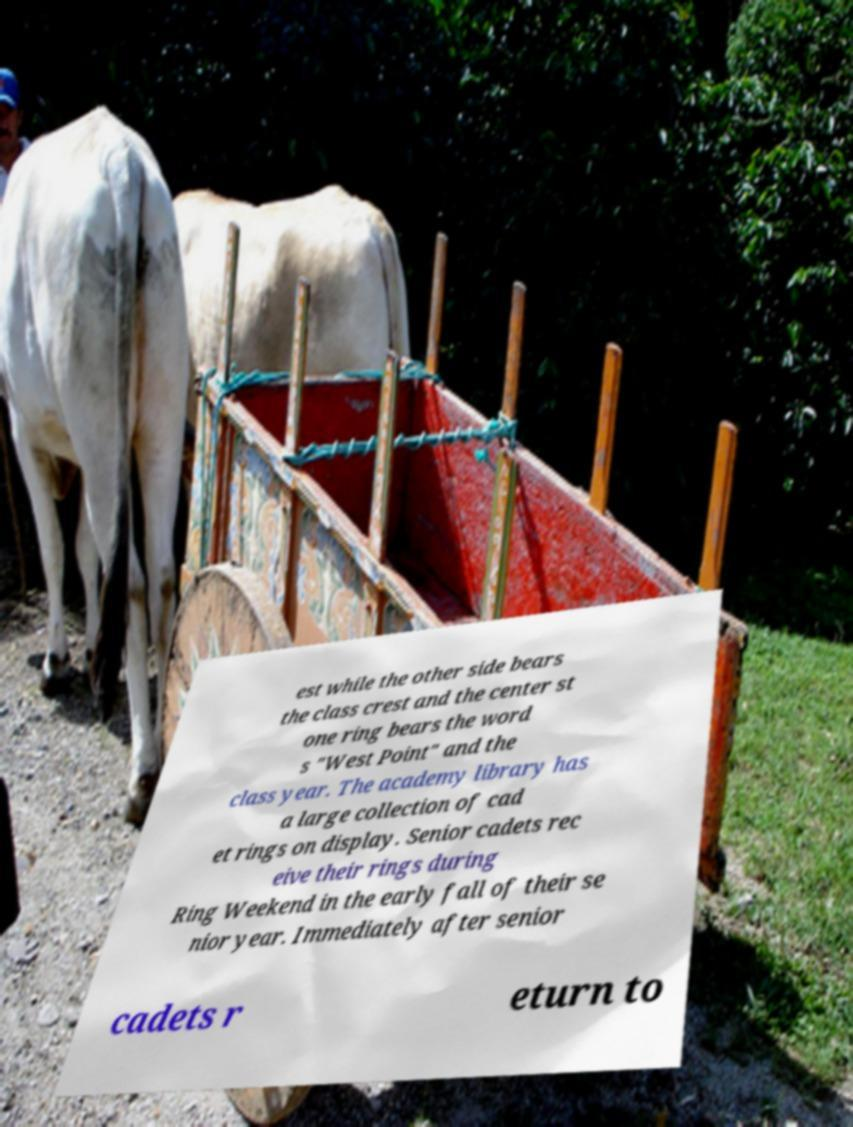Can you accurately transcribe the text from the provided image for me? est while the other side bears the class crest and the center st one ring bears the word s "West Point" and the class year. The academy library has a large collection of cad et rings on display. Senior cadets rec eive their rings during Ring Weekend in the early fall of their se nior year. Immediately after senior cadets r eturn to 